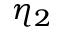<formula> <loc_0><loc_0><loc_500><loc_500>\eta _ { 2 }</formula> 